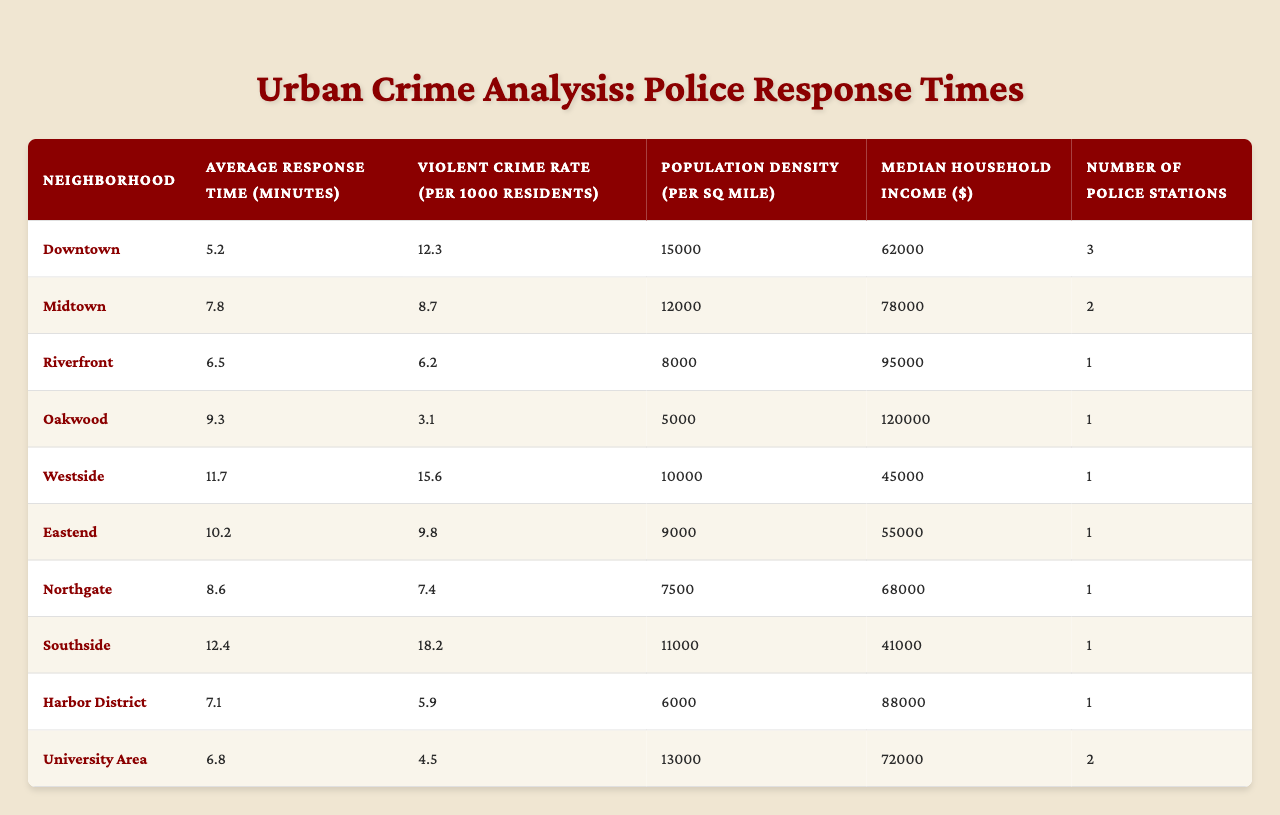What is the average response time in the Downtown neighborhood? The table shows the "Average Response Time" for the Downtown neighborhood is listed as 5.2 minutes. Hence, this is the answer.
Answer: 5.2 minutes Which neighborhood has the highest violent crime rate? The neighborhood with the highest "Violent Crime Rate" is Southside, with a rate of 18.2 per 1000 residents.
Answer: Southside What is the median household income for Westside? The table indicates that the "Median Household Income" for the Westside neighborhood is $45,000.
Answer: $45,000 How many police stations are in the Riverfront neighborhood? The number of police stations listed for Riverfront is 1, according to the table.
Answer: 1 What is the difference in average response time between Oakwood and Midtown? Oakwood's average response time is 9.3 minutes, and Midtown's is 7.8 minutes. The difference is 9.3 - 7.8 = 1.5 minutes.
Answer: 1.5 minutes Is it true that Northgate has a higher population density than University Area? Northgate's density is 7,500 per square mile, while University Area's is 13,000 per square mile. Therefore, the statement is false.
Answer: No Which neighborhood has the lowest median household income, and what is that income? The table shows Southside has the lowest median household income of $41,000.
Answer: Southside, $41,000 If we add the average response times of Downtown, Midtown, and Riverfront, what is the sum? The average response times are 5.2 (Downtown) + 7.8 (Midtown) + 6.5 (Riverfront) = 19.5 minutes.
Answer: 19.5 minutes What is the relationship between violent crime rate and median household income in the neighborhoods listed? Observing the table shows that neighborhoods with higher violent crime rates (like Southside) often have lower median incomes, indicating a possible negative correlation.
Answer: Negative correlation Which neighborhood has a response time greater than 10 minutes and a violent crime rate over 15 per 1000 residents? According to the table, Southside is the only neighborhood that fits this criterion: it has an average response time of 12.4 minutes and a violent crime rate of 18.2.
Answer: Southside 